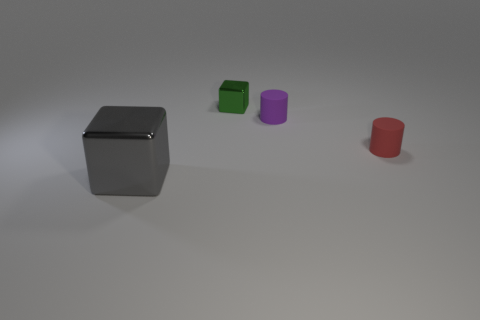What shape is the object that is in front of the purple thing and behind the big metal thing?
Make the answer very short. Cylinder. There is a large metallic block; does it have the same color as the metal cube behind the big gray metal thing?
Provide a short and direct response. No. What color is the block that is behind the red matte thing that is in front of the shiny cube that is behind the big gray shiny object?
Ensure brevity in your answer.  Green. There is a tiny thing that is the same shape as the large gray object; what color is it?
Provide a succinct answer. Green. There is a large block that is made of the same material as the tiny block; what is its color?
Give a very brief answer. Gray. Are the purple cylinder and the cube in front of the tiny purple rubber cylinder made of the same material?
Give a very brief answer. No. Are there any gray shiny things that have the same shape as the small purple matte object?
Your answer should be compact. No. How many tiny cylinders are behind the tiny purple matte thing?
Ensure brevity in your answer.  0. What is the material of the cube behind the cube in front of the green metal thing?
Make the answer very short. Metal. There is a purple cylinder that is the same size as the green metal block; what material is it?
Your answer should be compact. Rubber. 